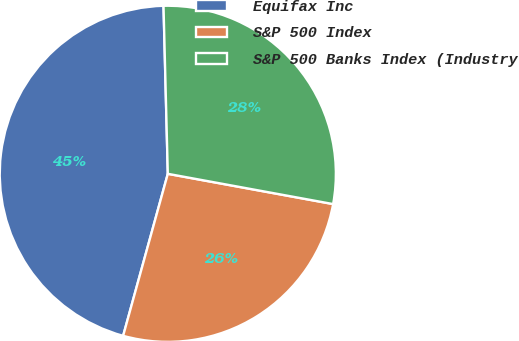Convert chart to OTSL. <chart><loc_0><loc_0><loc_500><loc_500><pie_chart><fcel>Equifax Inc<fcel>S&P 500 Index<fcel>S&P 500 Banks Index (Industry<nl><fcel>45.31%<fcel>26.4%<fcel>28.29%<nl></chart> 